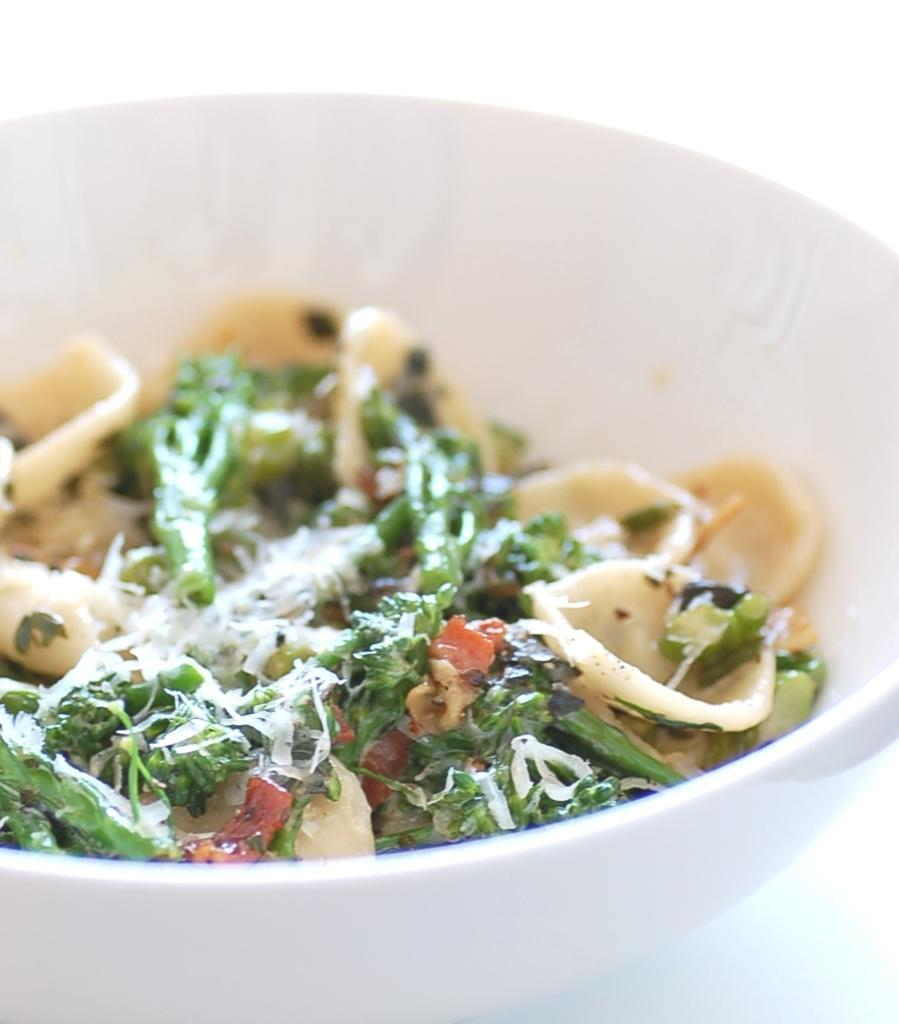What color is the bowl that is visible in the image? The bowl in the image is white. What is inside the bowl? There are food items in the bowl. Where is the coach located in the image? There is no coach present in the image. What type of farm animals can be seen in the image? There are no farm animals present in the image. 